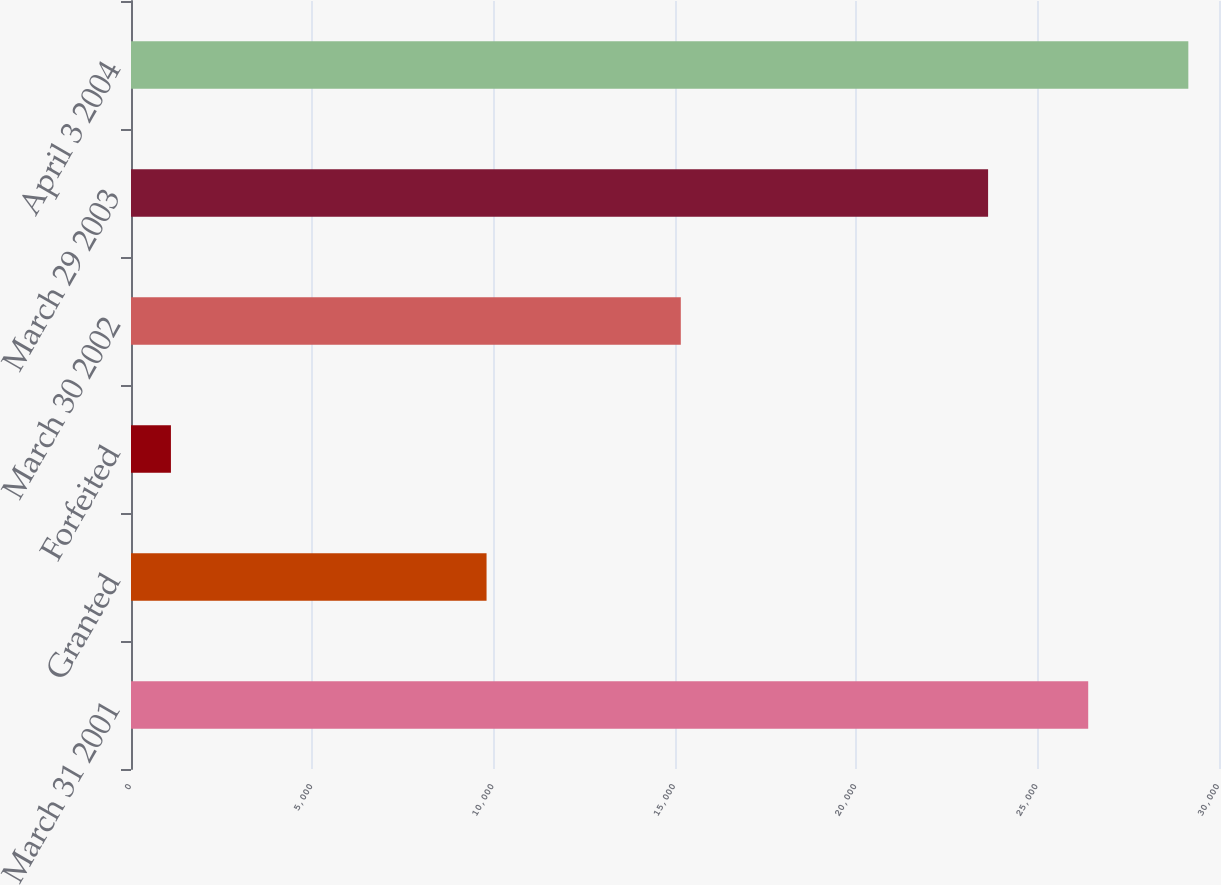Convert chart to OTSL. <chart><loc_0><loc_0><loc_500><loc_500><bar_chart><fcel>March 31 2001<fcel>Granted<fcel>Forfeited<fcel>March 30 2002<fcel>March 29 2003<fcel>April 3 2004<nl><fcel>26393.6<fcel>9804<fcel>1101<fcel>15160<fcel>23633<fcel>29154.2<nl></chart> 